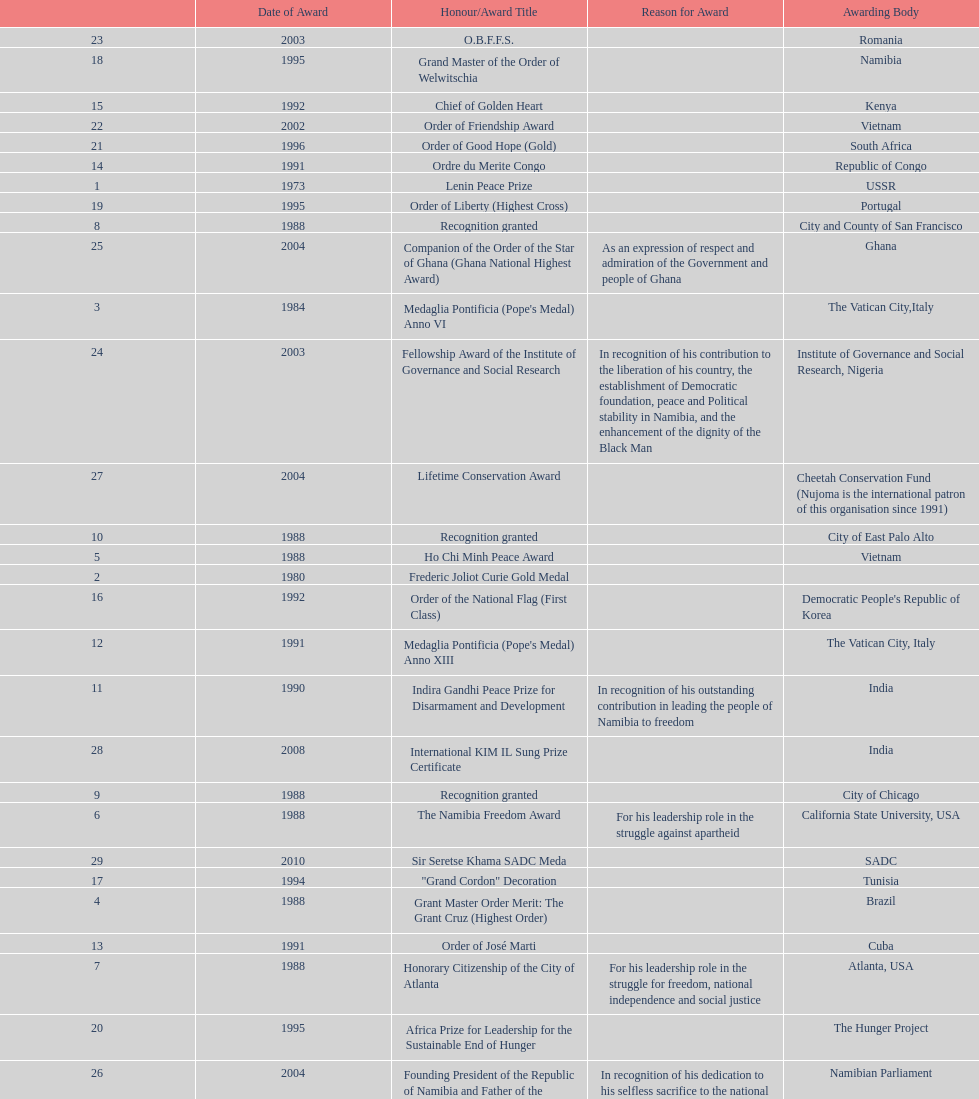What is the last honors/award title listed on this chart? Sir Seretse Khama SADC Meda. 